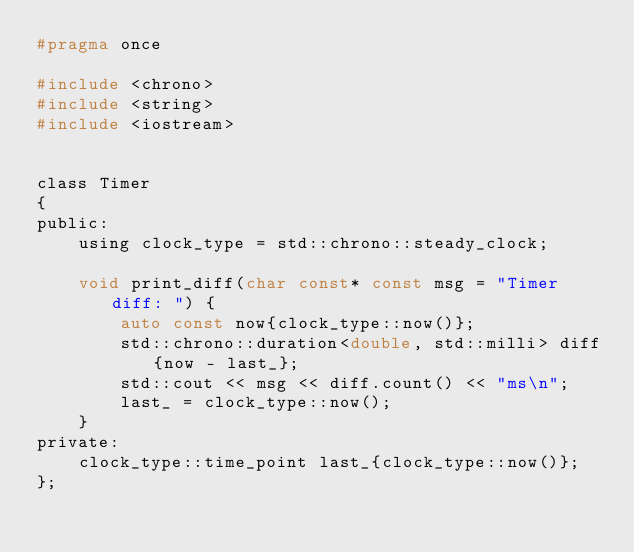Convert code to text. <code><loc_0><loc_0><loc_500><loc_500><_C_>#pragma once

#include <chrono>
#include <string>
#include <iostream>


class Timer
{
public:
    using clock_type = std::chrono::steady_clock;

    void print_diff(char const* const msg = "Timer diff: ") {
        auto const now{clock_type::now()};
        std::chrono::duration<double, std::milli> diff{now - last_};
        std::cout << msg << diff.count() << "ms\n";
        last_ = clock_type::now();
    }
private:
    clock_type::time_point last_{clock_type::now()};
};
</code> 